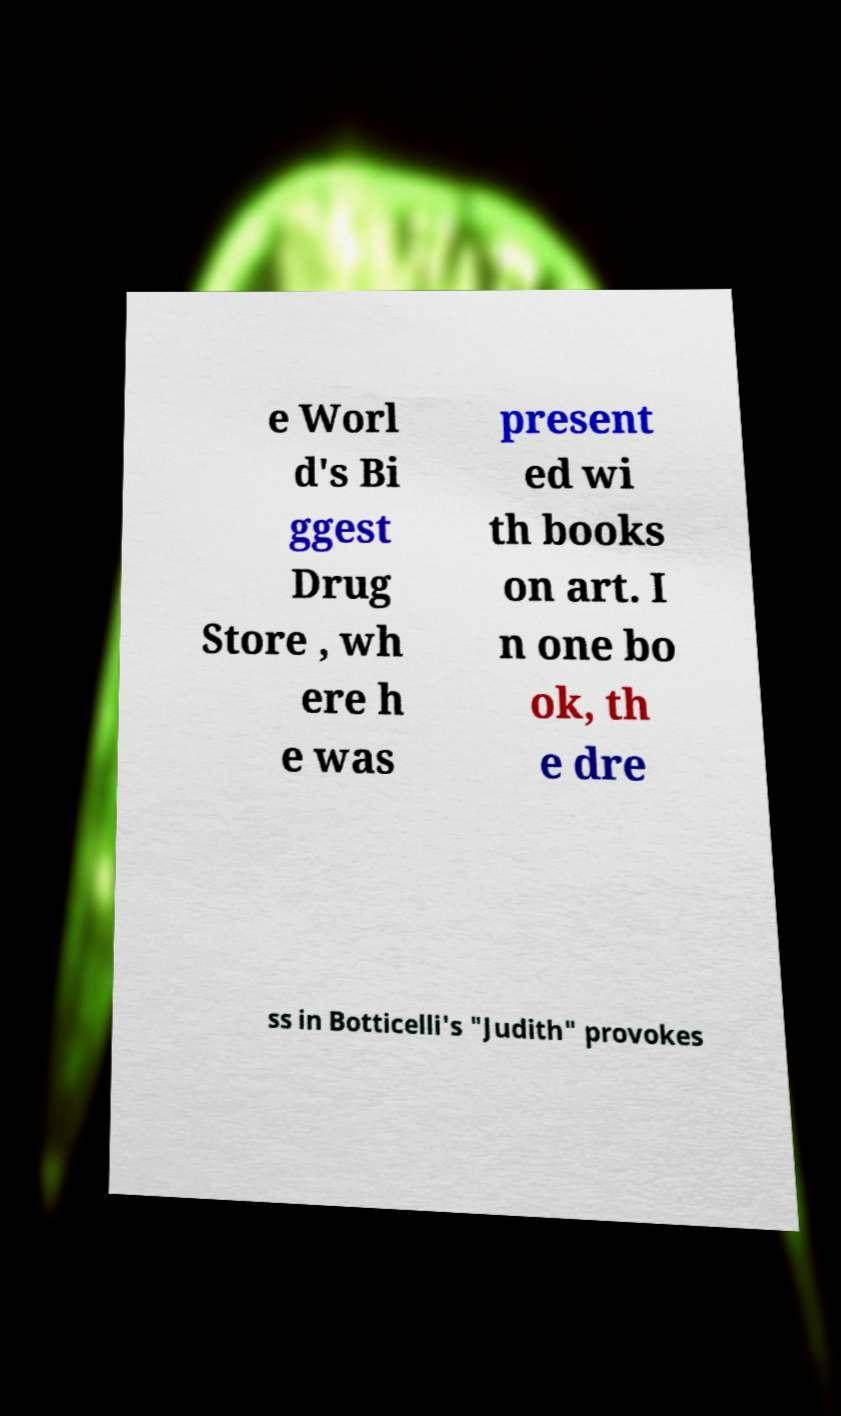Please identify and transcribe the text found in this image. e Worl d's Bi ggest Drug Store , wh ere h e was present ed wi th books on art. I n one bo ok, th e dre ss in Botticelli's "Judith" provokes 